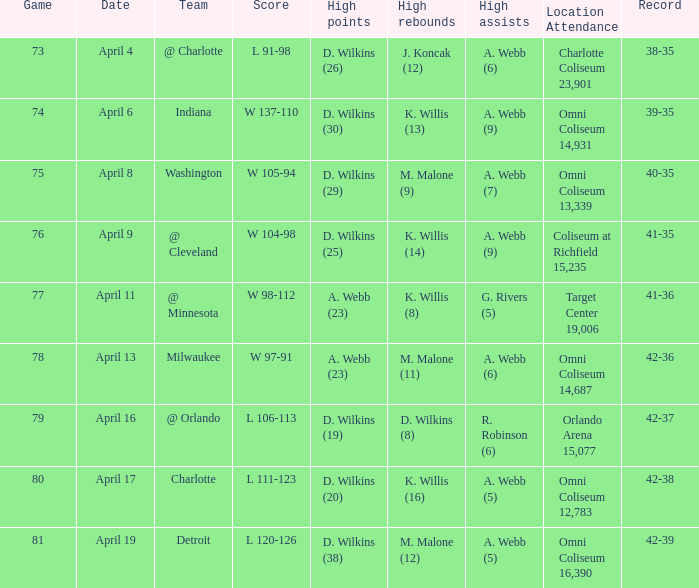How many people had the high points when a. webb (7) had the high assists? 1.0. 